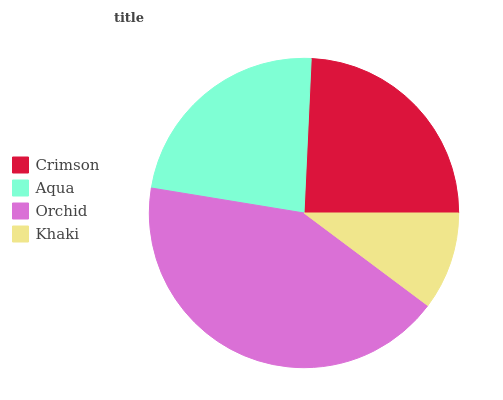Is Khaki the minimum?
Answer yes or no. Yes. Is Orchid the maximum?
Answer yes or no. Yes. Is Aqua the minimum?
Answer yes or no. No. Is Aqua the maximum?
Answer yes or no. No. Is Crimson greater than Aqua?
Answer yes or no. Yes. Is Aqua less than Crimson?
Answer yes or no. Yes. Is Aqua greater than Crimson?
Answer yes or no. No. Is Crimson less than Aqua?
Answer yes or no. No. Is Crimson the high median?
Answer yes or no. Yes. Is Aqua the low median?
Answer yes or no. Yes. Is Khaki the high median?
Answer yes or no. No. Is Khaki the low median?
Answer yes or no. No. 